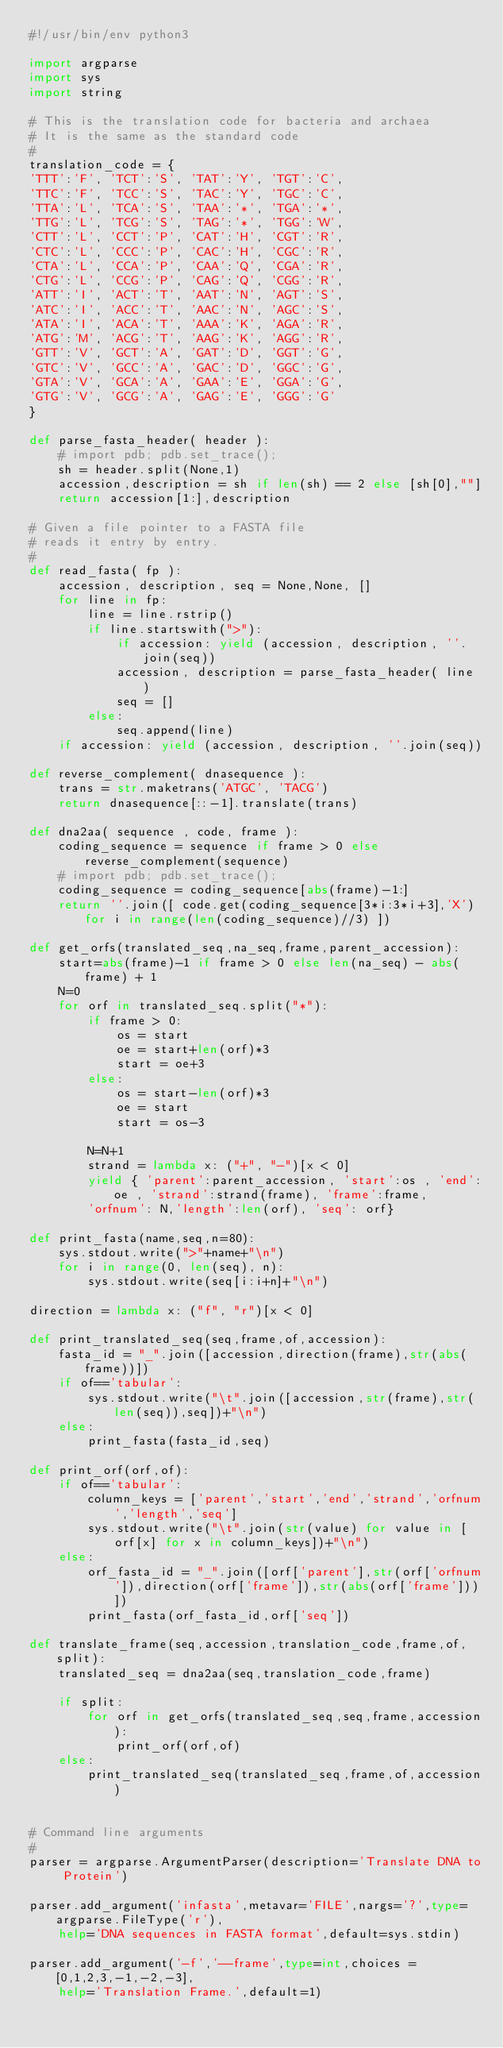Convert code to text. <code><loc_0><loc_0><loc_500><loc_500><_Python_>#!/usr/bin/env python3

import argparse
import sys
import string

# This is the translation code for bacteria and archaea
# It is the same as the standard code
#
translation_code = {
'TTT':'F', 'TCT':'S', 'TAT':'Y', 'TGT':'C',
'TTC':'F', 'TCC':'S', 'TAC':'Y', 'TGC':'C',
'TTA':'L', 'TCA':'S', 'TAA':'*', 'TGA':'*',
'TTG':'L', 'TCG':'S', 'TAG':'*', 'TGG':'W',
'CTT':'L', 'CCT':'P', 'CAT':'H', 'CGT':'R',
'CTC':'L', 'CCC':'P', 'CAC':'H', 'CGC':'R',
'CTA':'L', 'CCA':'P', 'CAA':'Q', 'CGA':'R',
'CTG':'L', 'CCG':'P', 'CAG':'Q', 'CGG':'R',
'ATT':'I', 'ACT':'T', 'AAT':'N', 'AGT':'S',
'ATC':'I', 'ACC':'T', 'AAC':'N', 'AGC':'S',
'ATA':'I', 'ACA':'T', 'AAA':'K', 'AGA':'R',
'ATG':'M', 'ACG':'T', 'AAG':'K', 'AGG':'R',
'GTT':'V', 'GCT':'A', 'GAT':'D', 'GGT':'G',
'GTC':'V', 'GCC':'A', 'GAC':'D', 'GGC':'G',
'GTA':'V', 'GCA':'A', 'GAA':'E', 'GGA':'G',
'GTG':'V', 'GCG':'A', 'GAG':'E', 'GGG':'G'	
}

def parse_fasta_header( header ):
	# import pdb; pdb.set_trace();
	sh = header.split(None,1)
	accession,description = sh if len(sh) == 2 else [sh[0],""]
	return accession[1:],description

# Given a file pointer to a FASTA file
# reads it entry by entry.
# 
def read_fasta( fp ):
	accession, description, seq = None,None, []
	for line in fp:
		line = line.rstrip()
		if line.startswith(">"):
			if accession: yield (accession, description, ''.join(seq))
			accession, description = parse_fasta_header( line )
			seq = []
		else:
			seq.append(line)
	if accession: yield (accession, description, ''.join(seq))

def reverse_complement( dnasequence ):
	trans = str.maketrans('ATGC', 'TACG')
	return dnasequence[::-1].translate(trans)

def dna2aa( sequence , code, frame ):
	coding_sequence = sequence if frame > 0 else reverse_complement(sequence)
	# import pdb; pdb.set_trace();
	coding_sequence = coding_sequence[abs(frame)-1:]
	return ''.join([ code.get(coding_sequence[3*i:3*i+3],'X') for i in range(len(coding_sequence)//3) ])

def get_orfs(translated_seq,na_seq,frame,parent_accession):
	start=abs(frame)-1 if frame > 0 else len(na_seq) - abs(frame) + 1
	N=0
	for orf in translated_seq.split("*"):
		if frame > 0:
			os = start
			oe = start+len(orf)*3
			start = oe+3
		else: 
			os = start-len(orf)*3
			oe = start
			start = os-3

		N=N+1
		strand = lambda x: ("+", "-")[x < 0]
		yield { 'parent':parent_accession, 'start':os , 'end':oe , 'strand':strand(frame), 'frame':frame,
		'orfnum': N,'length':len(orf), 'seq': orf}

def print_fasta(name,seq,n=80):
	sys.stdout.write(">"+name+"\n")
	for i in range(0, len(seq), n):
		sys.stdout.write(seq[i:i+n]+"\n")

direction = lambda x: ("f", "r")[x < 0]

def print_translated_seq(seq,frame,of,accession):
	fasta_id = "_".join([accession,direction(frame),str(abs(frame))])
	if of=='tabular':
		sys.stdout.write("\t".join([accession,str(frame),str(len(seq)),seq])+"\n")
	else:
		print_fasta(fasta_id,seq)

def print_orf(orf,of):
	if of=='tabular':
		column_keys = ['parent','start','end','strand','orfnum','length','seq']
		sys.stdout.write("\t".join(str(value) for value in [orf[x] for x in column_keys])+"\n")
	else:
		orf_fasta_id = "_".join([orf['parent'],str(orf['orfnum']),direction(orf['frame']),str(abs(orf['frame']))])
		print_fasta(orf_fasta_id,orf['seq'])

def translate_frame(seq,accession,translation_code,frame,of,split):
	translated_seq = dna2aa(seq,translation_code,frame)

	if split:
		for orf in get_orfs(translated_seq,seq,frame,accession):
			print_orf(orf,of)
	else:
		print_translated_seq(translated_seq,frame,of,accession)


# Command line arguments
#
parser = argparse.ArgumentParser(description='Translate DNA to Protein')

parser.add_argument('infasta',metavar='FILE',nargs='?',type=argparse.FileType('r'),
	help='DNA sequences in FASTA format',default=sys.stdin)

parser.add_argument('-f','--frame',type=int,choices = [0,1,2,3,-1,-2,-3],
	help='Translation Frame.',default=1)
</code> 